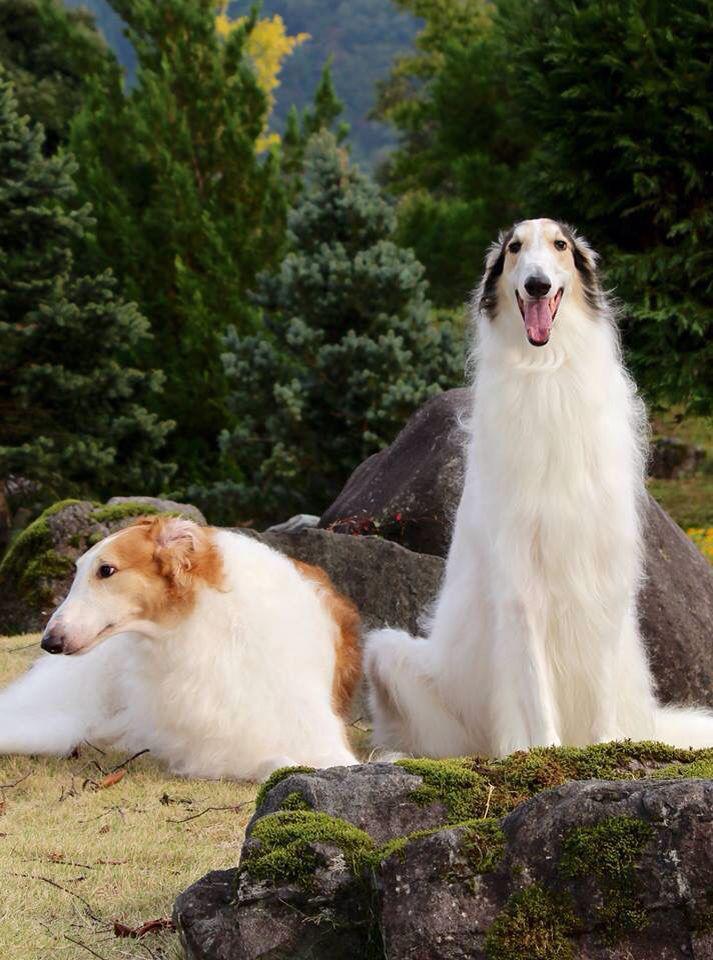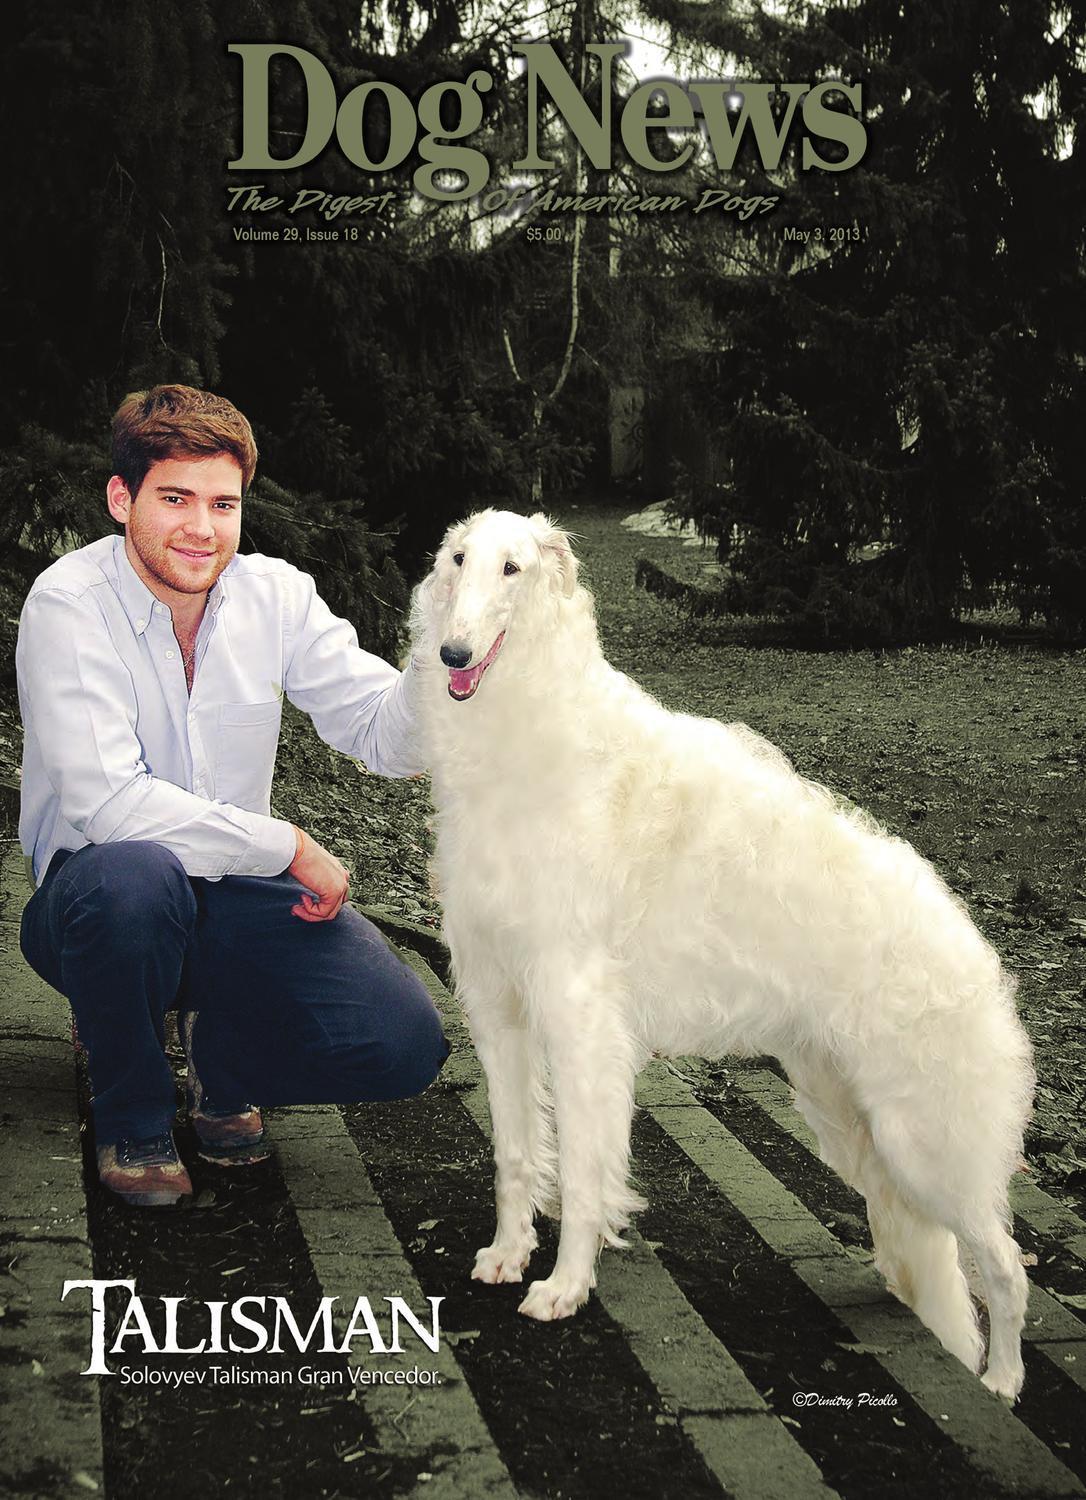The first image is the image on the left, the second image is the image on the right. Analyze the images presented: Is the assertion "There are more than two dogs." valid? Answer yes or no. Yes. 